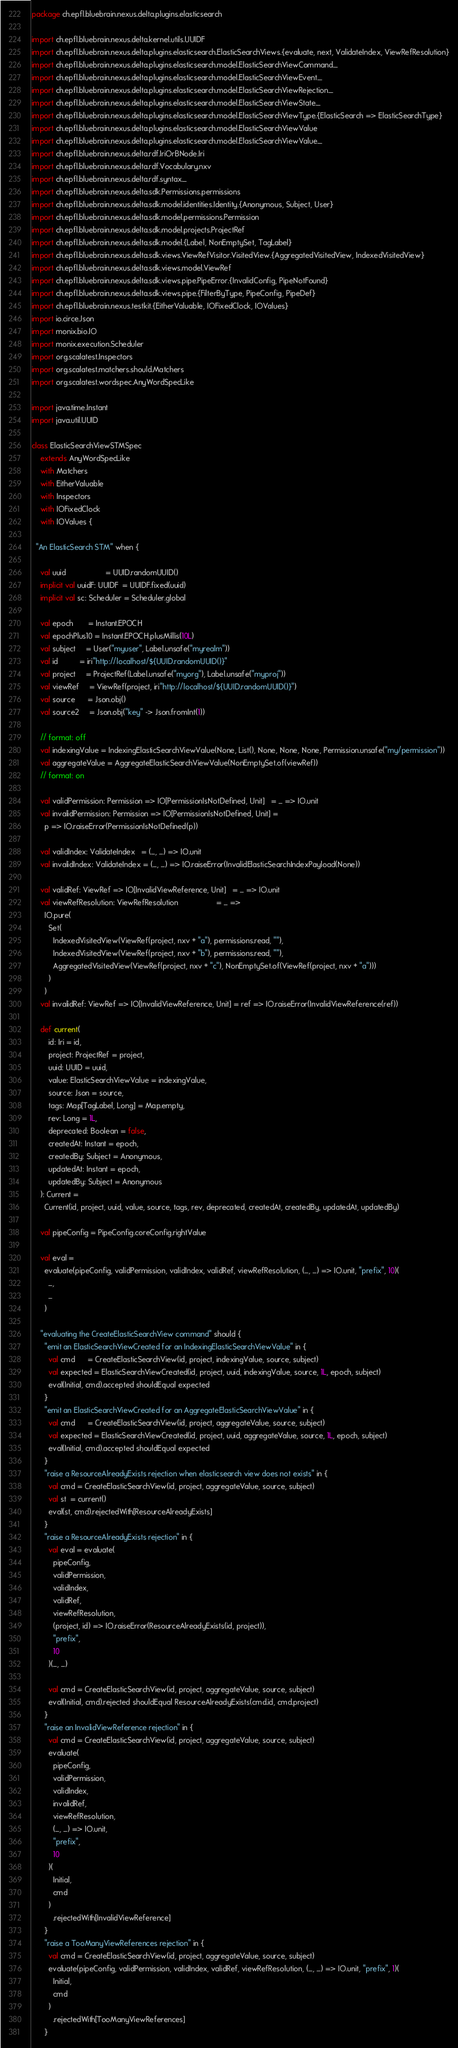<code> <loc_0><loc_0><loc_500><loc_500><_Scala_>package ch.epfl.bluebrain.nexus.delta.plugins.elasticsearch

import ch.epfl.bluebrain.nexus.delta.kernel.utils.UUIDF
import ch.epfl.bluebrain.nexus.delta.plugins.elasticsearch.ElasticSearchViews.{evaluate, next, ValidateIndex, ViewRefResolution}
import ch.epfl.bluebrain.nexus.delta.plugins.elasticsearch.model.ElasticSearchViewCommand._
import ch.epfl.bluebrain.nexus.delta.plugins.elasticsearch.model.ElasticSearchViewEvent._
import ch.epfl.bluebrain.nexus.delta.plugins.elasticsearch.model.ElasticSearchViewRejection._
import ch.epfl.bluebrain.nexus.delta.plugins.elasticsearch.model.ElasticSearchViewState._
import ch.epfl.bluebrain.nexus.delta.plugins.elasticsearch.model.ElasticSearchViewType.{ElasticSearch => ElasticSearchType}
import ch.epfl.bluebrain.nexus.delta.plugins.elasticsearch.model.ElasticSearchViewValue
import ch.epfl.bluebrain.nexus.delta.plugins.elasticsearch.model.ElasticSearchViewValue._
import ch.epfl.bluebrain.nexus.delta.rdf.IriOrBNode.Iri
import ch.epfl.bluebrain.nexus.delta.rdf.Vocabulary.nxv
import ch.epfl.bluebrain.nexus.delta.rdf.syntax._
import ch.epfl.bluebrain.nexus.delta.sdk.Permissions.permissions
import ch.epfl.bluebrain.nexus.delta.sdk.model.identities.Identity.{Anonymous, Subject, User}
import ch.epfl.bluebrain.nexus.delta.sdk.model.permissions.Permission
import ch.epfl.bluebrain.nexus.delta.sdk.model.projects.ProjectRef
import ch.epfl.bluebrain.nexus.delta.sdk.model.{Label, NonEmptySet, TagLabel}
import ch.epfl.bluebrain.nexus.delta.sdk.views.ViewRefVisitor.VisitedView.{AggregatedVisitedView, IndexedVisitedView}
import ch.epfl.bluebrain.nexus.delta.sdk.views.model.ViewRef
import ch.epfl.bluebrain.nexus.delta.sdk.views.pipe.PipeError.{InvalidConfig, PipeNotFound}
import ch.epfl.bluebrain.nexus.delta.sdk.views.pipe.{FilterByType, PipeConfig, PipeDef}
import ch.epfl.bluebrain.nexus.testkit.{EitherValuable, IOFixedClock, IOValues}
import io.circe.Json
import monix.bio.IO
import monix.execution.Scheduler
import org.scalatest.Inspectors
import org.scalatest.matchers.should.Matchers
import org.scalatest.wordspec.AnyWordSpecLike

import java.time.Instant
import java.util.UUID

class ElasticSearchViewSTMSpec
    extends AnyWordSpecLike
    with Matchers
    with EitherValuable
    with Inspectors
    with IOFixedClock
    with IOValues {

  "An ElasticSearch STM" when {

    val uuid                   = UUID.randomUUID()
    implicit val uuidF: UUIDF  = UUIDF.fixed(uuid)
    implicit val sc: Scheduler = Scheduler.global

    val epoch       = Instant.EPOCH
    val epochPlus10 = Instant.EPOCH.plusMillis(10L)
    val subject     = User("myuser", Label.unsafe("myrealm"))
    val id          = iri"http://localhost/${UUID.randomUUID()}"
    val project     = ProjectRef(Label.unsafe("myorg"), Label.unsafe("myproj"))
    val viewRef     = ViewRef(project, iri"http://localhost/${UUID.randomUUID()}")
    val source      = Json.obj()
    val source2     = Json.obj("key" -> Json.fromInt(1))

    // format: off
    val indexingValue = IndexingElasticSearchViewValue(None, List(), None, None, None, Permission.unsafe("my/permission"))
    val aggregateValue = AggregateElasticSearchViewValue(NonEmptySet.of(viewRef))
    // format: on

    val validPermission: Permission => IO[PermissionIsNotDefined, Unit]   = _ => IO.unit
    val invalidPermission: Permission => IO[PermissionIsNotDefined, Unit] =
      p => IO.raiseError(PermissionIsNotDefined(p))

    val validIndex: ValidateIndex   = (_, _) => IO.unit
    val invalidIndex: ValidateIndex = (_, _) => IO.raiseError(InvalidElasticSearchIndexPayload(None))

    val validRef: ViewRef => IO[InvalidViewReference, Unit]   = _ => IO.unit
    val viewRefResolution: ViewRefResolution                  = _ =>
      IO.pure(
        Set(
          IndexedVisitedView(ViewRef(project, nxv + "a"), permissions.read, ""),
          IndexedVisitedView(ViewRef(project, nxv + "b"), permissions.read, ""),
          AggregatedVisitedView(ViewRef(project, nxv + "c"), NonEmptySet.of(ViewRef(project, nxv + "a")))
        )
      )
    val invalidRef: ViewRef => IO[InvalidViewReference, Unit] = ref => IO.raiseError(InvalidViewReference(ref))

    def current(
        id: Iri = id,
        project: ProjectRef = project,
        uuid: UUID = uuid,
        value: ElasticSearchViewValue = indexingValue,
        source: Json = source,
        tags: Map[TagLabel, Long] = Map.empty,
        rev: Long = 1L,
        deprecated: Boolean = false,
        createdAt: Instant = epoch,
        createdBy: Subject = Anonymous,
        updatedAt: Instant = epoch,
        updatedBy: Subject = Anonymous
    ): Current =
      Current(id, project, uuid, value, source, tags, rev, deprecated, createdAt, createdBy, updatedAt, updatedBy)

    val pipeConfig = PipeConfig.coreConfig.rightValue

    val eval =
      evaluate(pipeConfig, validPermission, validIndex, validRef, viewRefResolution, (_, _) => IO.unit, "prefix", 10)(
        _,
        _
      )

    "evaluating the CreateElasticSearchView command" should {
      "emit an ElasticSearchViewCreated for an IndexingElasticSearchViewValue" in {
        val cmd      = CreateElasticSearchView(id, project, indexingValue, source, subject)
        val expected = ElasticSearchViewCreated(id, project, uuid, indexingValue, source, 1L, epoch, subject)
        eval(Initial, cmd).accepted shouldEqual expected
      }
      "emit an ElasticSearchViewCreated for an AggregateElasticSearchViewValue" in {
        val cmd      = CreateElasticSearchView(id, project, aggregateValue, source, subject)
        val expected = ElasticSearchViewCreated(id, project, uuid, aggregateValue, source, 1L, epoch, subject)
        eval(Initial, cmd).accepted shouldEqual expected
      }
      "raise a ResourceAlreadyExists rejection when elasticsearch view does not exists" in {
        val cmd = CreateElasticSearchView(id, project, aggregateValue, source, subject)
        val st  = current()
        eval(st, cmd).rejectedWith[ResourceAlreadyExists]
      }
      "raise a ResourceAlreadyExists rejection" in {
        val eval = evaluate(
          pipeConfig,
          validPermission,
          validIndex,
          validRef,
          viewRefResolution,
          (project, id) => IO.raiseError(ResourceAlreadyExists(id, project)),
          "prefix",
          10
        )(_, _)

        val cmd = CreateElasticSearchView(id, project, aggregateValue, source, subject)
        eval(Initial, cmd).rejected shouldEqual ResourceAlreadyExists(cmd.id, cmd.project)
      }
      "raise an InvalidViewReference rejection" in {
        val cmd = CreateElasticSearchView(id, project, aggregateValue, source, subject)
        evaluate(
          pipeConfig,
          validPermission,
          validIndex,
          invalidRef,
          viewRefResolution,
          (_, _) => IO.unit,
          "prefix",
          10
        )(
          Initial,
          cmd
        )
          .rejectedWith[InvalidViewReference]
      }
      "raise a TooManyViewReferences rejection" in {
        val cmd = CreateElasticSearchView(id, project, aggregateValue, source, subject)
        evaluate(pipeConfig, validPermission, validIndex, validRef, viewRefResolution, (_, _) => IO.unit, "prefix", 1)(
          Initial,
          cmd
        )
          .rejectedWith[TooManyViewReferences]
      }</code> 